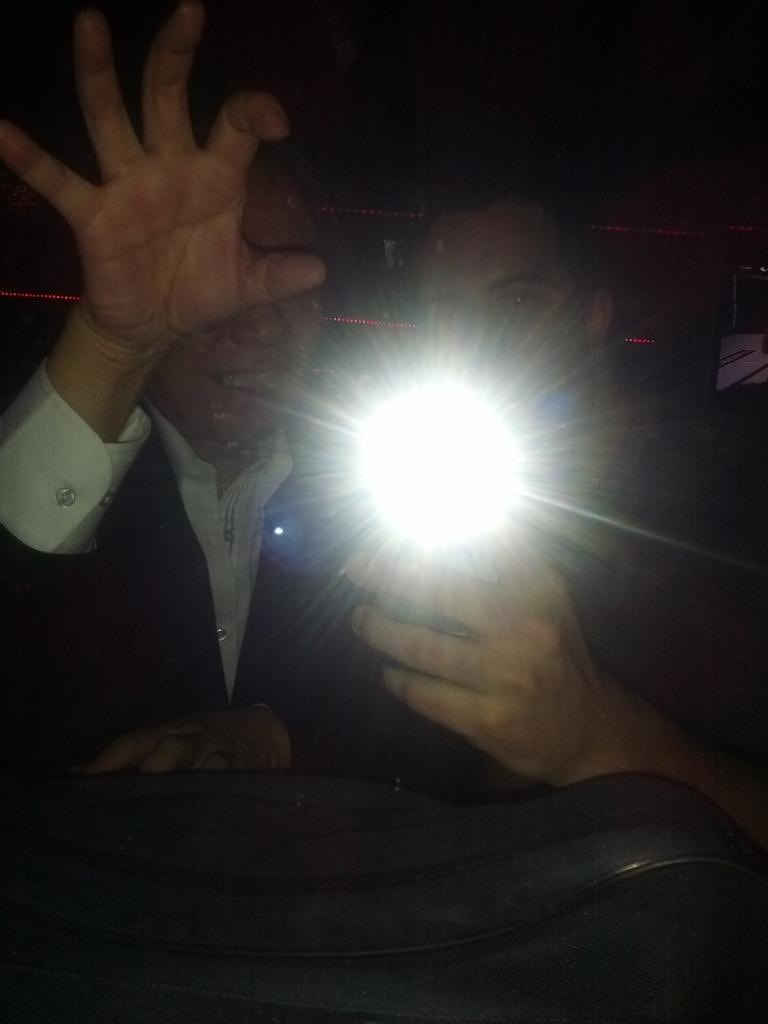How many people are in the image? There are two people in the image. What is the person on the right side holding? The person on the right side is holding a light. Can you describe the object at the bottom of the image? Unfortunately, the provided facts do not mention any specific object at the bottom of the image. How would you describe the lighting conditions in the image? The background of the image appears dark. What is the father's opinion about hate in the image? There is no mention of a father or the concept of hate in the image, so it is not possible to answer this question. 